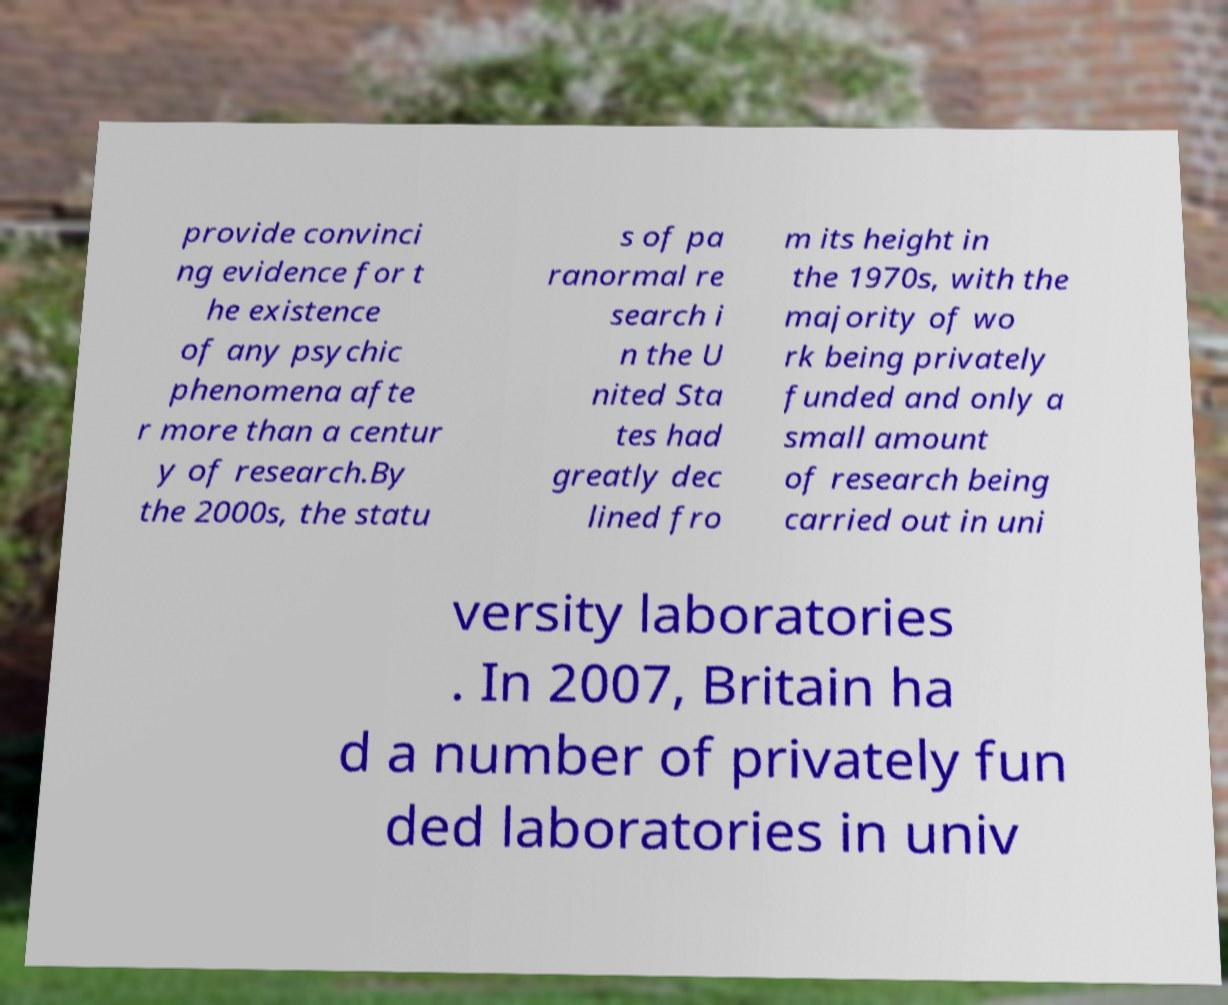Can you read and provide the text displayed in the image?This photo seems to have some interesting text. Can you extract and type it out for me? provide convinci ng evidence for t he existence of any psychic phenomena afte r more than a centur y of research.By the 2000s, the statu s of pa ranormal re search i n the U nited Sta tes had greatly dec lined fro m its height in the 1970s, with the majority of wo rk being privately funded and only a small amount of research being carried out in uni versity laboratories . In 2007, Britain ha d a number of privately fun ded laboratories in univ 